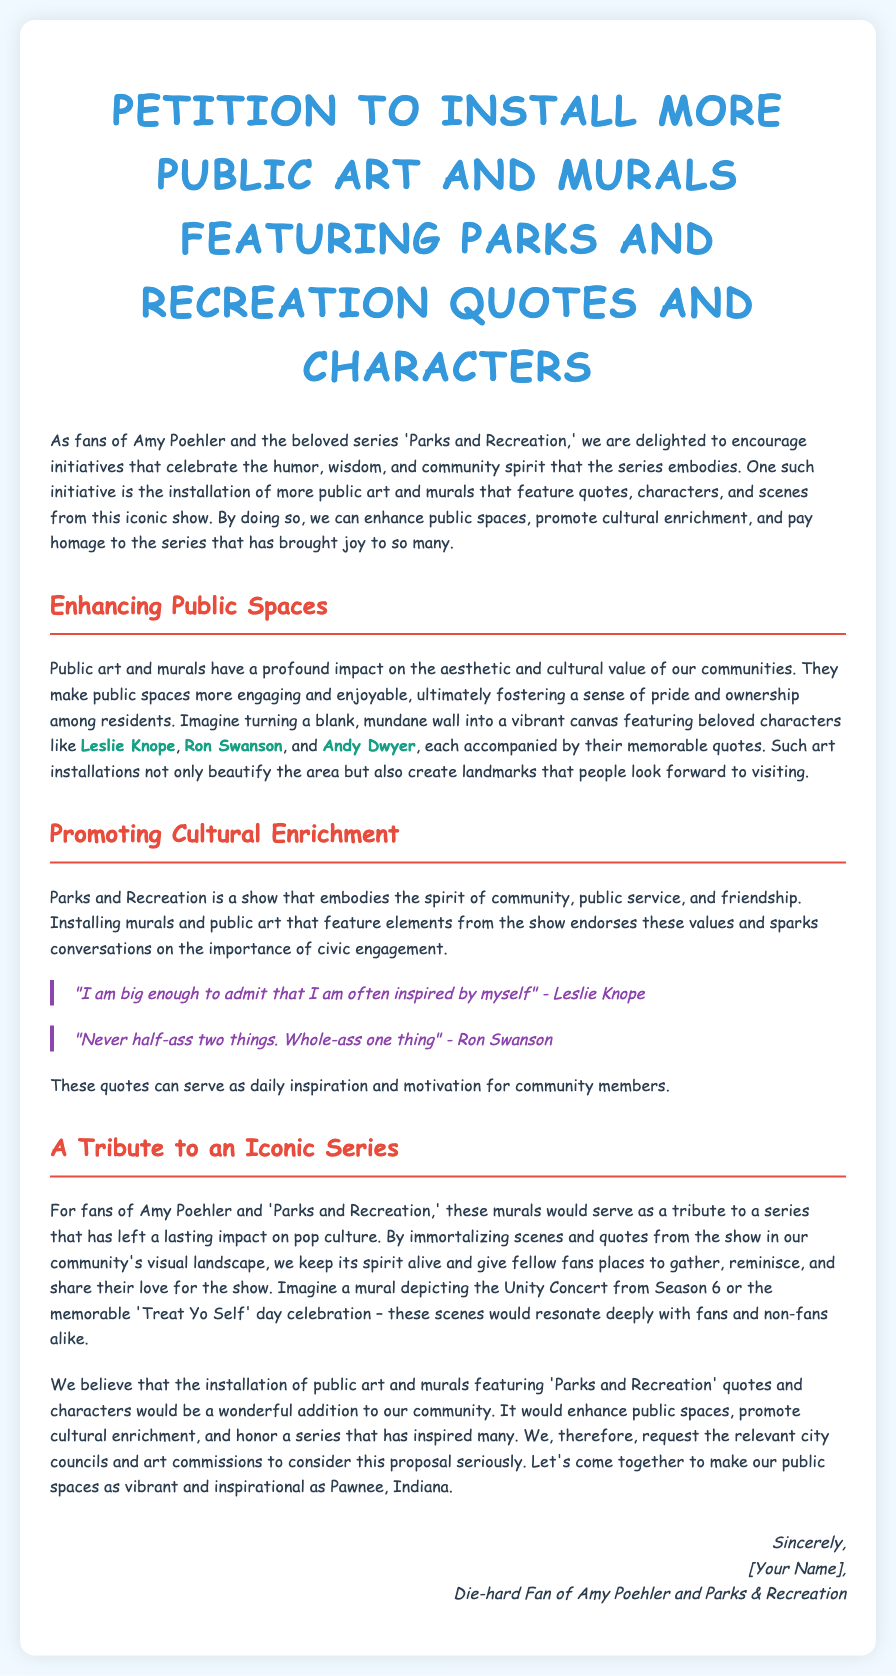What is the title of the petition? The title of the petition is explicitly stated at the top of the document.
Answer: Petition to Install More Public Art and Murals Featuring Parks and Recreation Quotes and Characters Who is mentioned as a significant character in the petition? The petition highlights several famous characters from the show, but one notable character is explicitly emphasized in the text.
Answer: Leslie Knope What is one quote from Leslie Knope mentioned in the petition? The document includes a specific quote attributed to Leslie Knope, showcasing her character's inspiration.
Answer: "I am big enough to admit that I am often inspired by myself" What is the purpose of installing public art according to the petition? The document states several reasons for installing public art, with a key purpose about enhancing community spaces and values.
Answer: Enhance public spaces What is one value that "Parks and Recreation" embodies? The document specifies themes and values represented in the show, which relate to the community and public service.
Answer: Community What event from "Parks and Recreation" is suggested for a mural? The petition proposes a specific event from the show as a potential mural, which resonates with fans.
Answer: Unity Concert How does the petition suggest public art will impact residents? The document describes the anticipated effect of public art as fostering a specific type of feeling in the community.
Answer: Sense of pride In which community does the petition suggest to install the murals? The petition refers to a fictional setting that fans fondly recognize in relation to the public art.
Answer: Pawnee, Indiana 